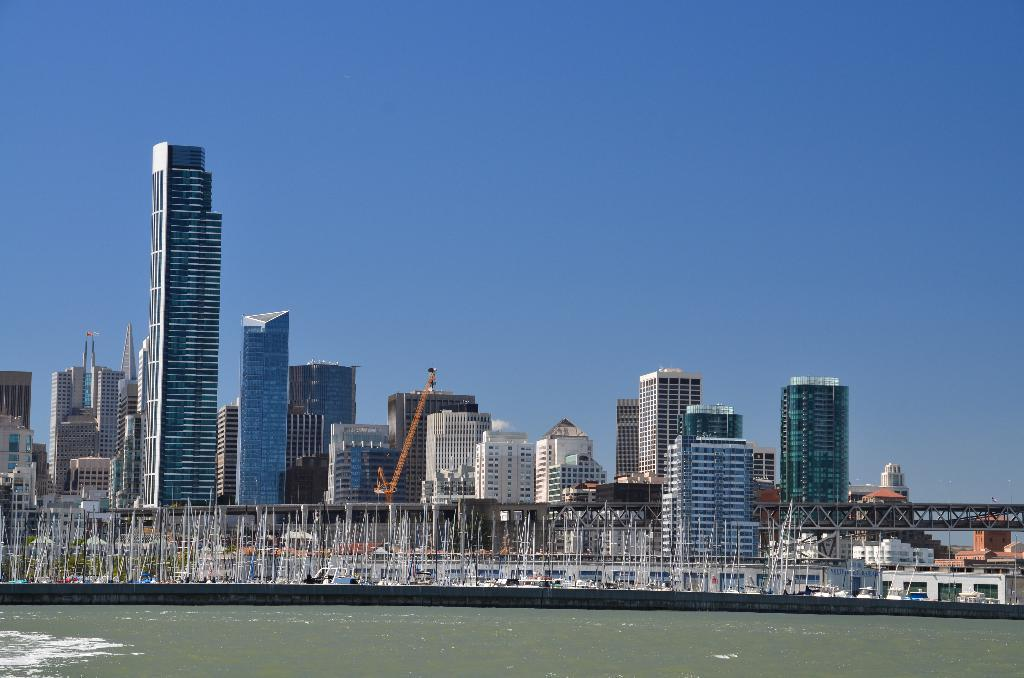What is the primary element visible in the image? There is water in the image. What type of structures can be seen in the image? There are buildings and bridges in the image. Where is your mom in the image? There is no person, including your mom, present in the image. What type of cave can be seen in the image? There is no cave present in the image; it features water, buildings, and bridges. 